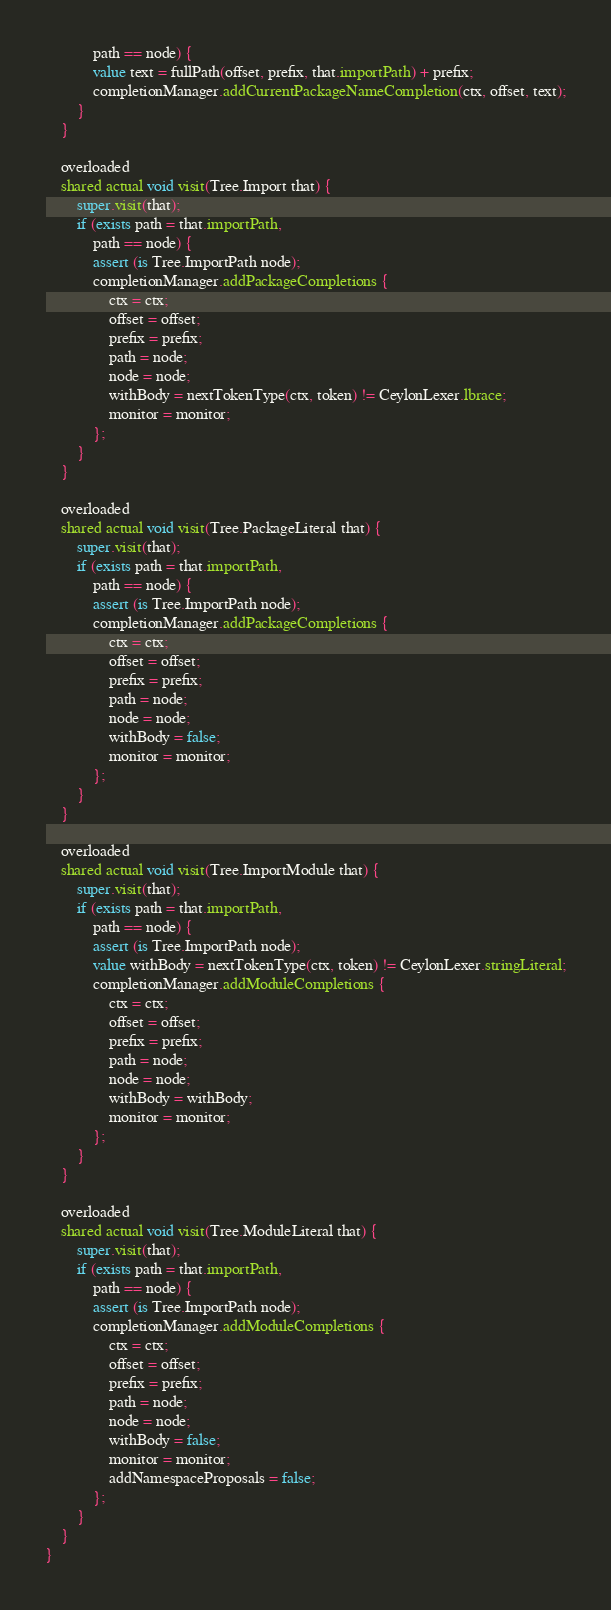<code> <loc_0><loc_0><loc_500><loc_500><_Ceylon_>            path == node) {
            value text = fullPath(offset, prefix, that.importPath) + prefix;
            completionManager.addCurrentPackageNameCompletion(ctx, offset, text);
        }
    }

    overloaded
    shared actual void visit(Tree.Import that) {
        super.visit(that);
        if (exists path = that.importPath,
            path == node) {
            assert (is Tree.ImportPath node);
            completionManager.addPackageCompletions {
                ctx = ctx;
                offset = offset;
                prefix = prefix;
                path = node;
                node = node;
                withBody = nextTokenType(ctx, token) != CeylonLexer.lbrace;
                monitor = monitor;
            };
        }
    }

    overloaded
    shared actual void visit(Tree.PackageLiteral that) {
        super.visit(that);
        if (exists path = that.importPath,
            path == node) {
            assert (is Tree.ImportPath node);
            completionManager.addPackageCompletions {
                ctx = ctx;
                offset = offset;
                prefix = prefix;
                path = node;
                node = node;
                withBody = false;
                monitor = monitor;
            };
        }
    }

    overloaded
    shared actual void visit(Tree.ImportModule that) {
        super.visit(that);
        if (exists path = that.importPath,
            path == node) {
            assert (is Tree.ImportPath node);
            value withBody = nextTokenType(ctx, token) != CeylonLexer.stringLiteral;
            completionManager.addModuleCompletions {
                ctx = ctx;
                offset = offset;
                prefix = prefix;
                path = node;
                node = node;
                withBody = withBody;
                monitor = monitor;
            };
        }
    }

    overloaded
    shared actual void visit(Tree.ModuleLiteral that) {
        super.visit(that);
        if (exists path = that.importPath,
            path == node) {
            assert (is Tree.ImportPath node);
            completionManager.addModuleCompletions {
                ctx = ctx;
                offset = offset;
                prefix = prefix;
                path = node;
                node = node;
                withBody = false;
                monitor = monitor;
                addNamespaceProposals = false;
            };
        }
    }
}
</code> 